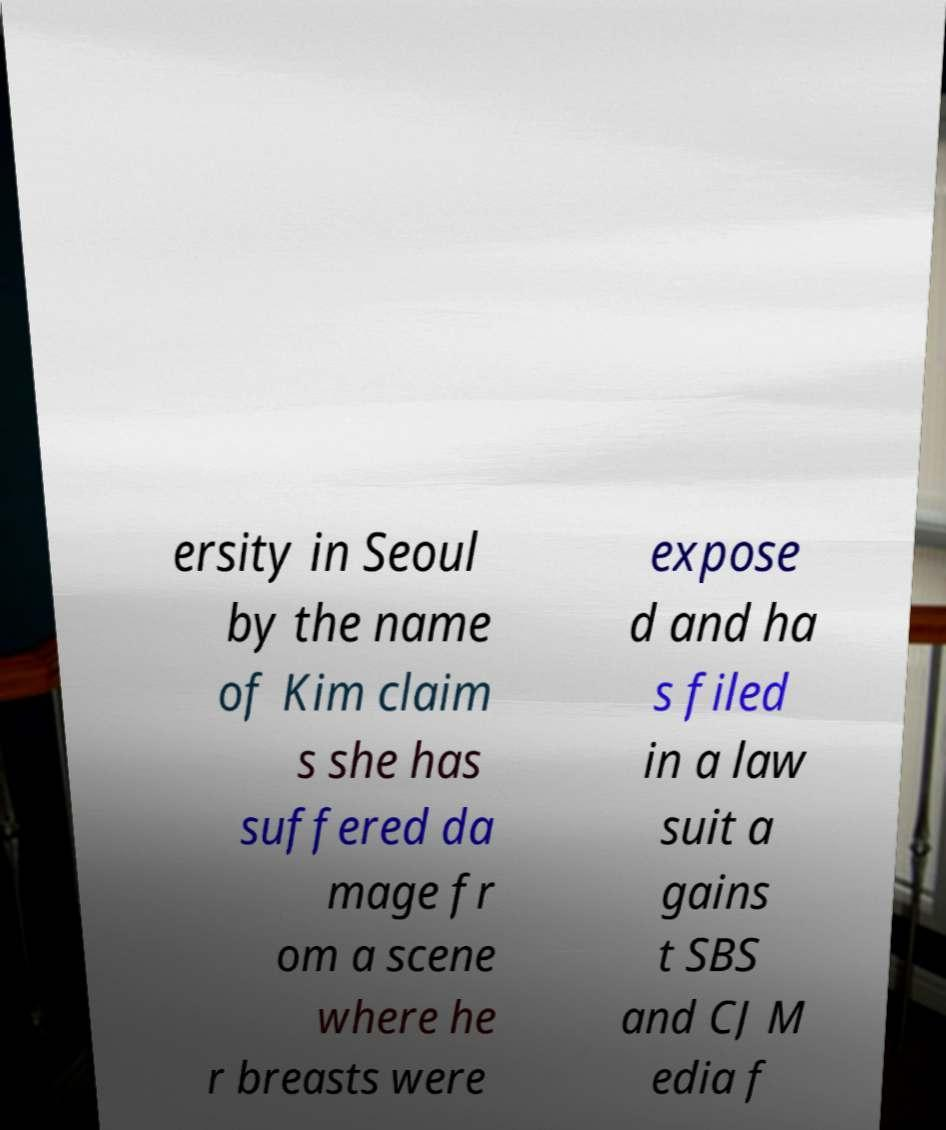Please identify and transcribe the text found in this image. ersity in Seoul by the name of Kim claim s she has suffered da mage fr om a scene where he r breasts were expose d and ha s filed in a law suit a gains t SBS and CJ M edia f 